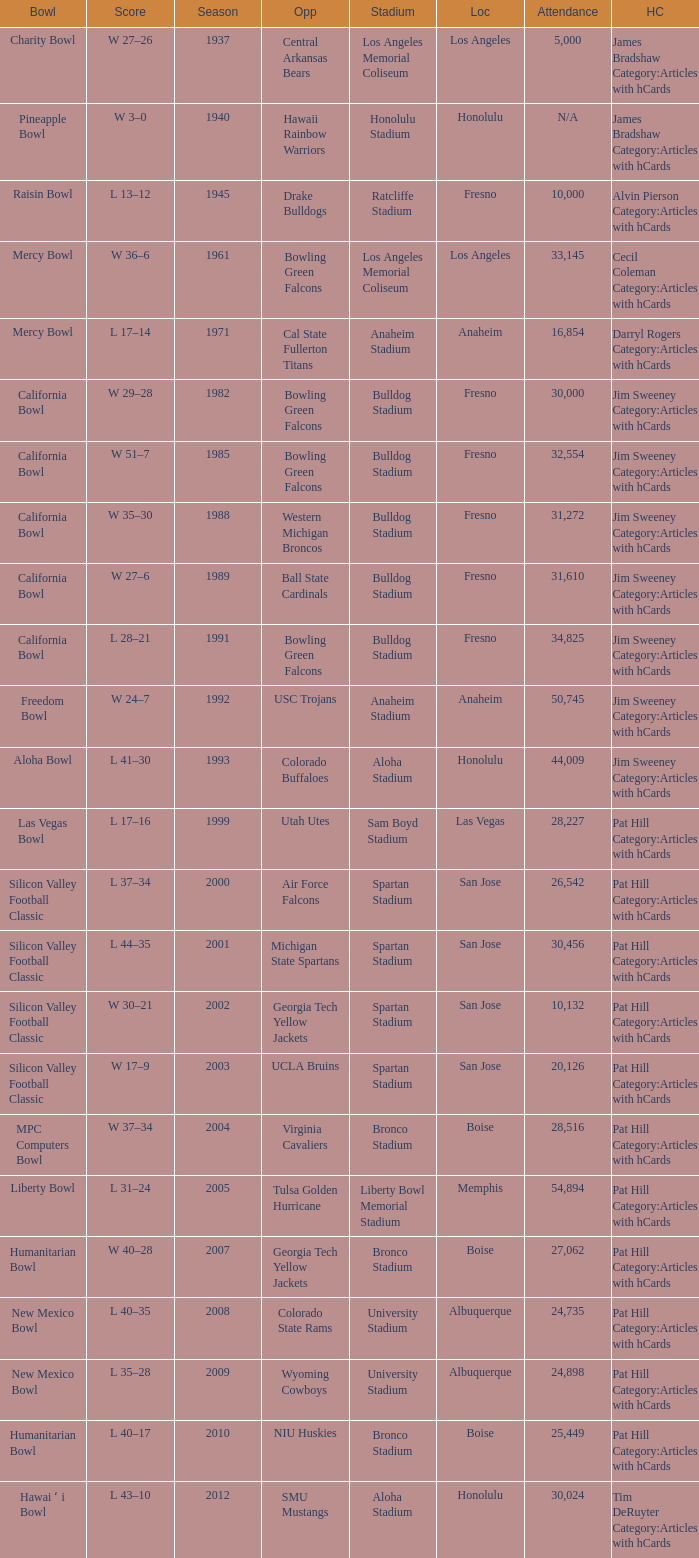Where was the California bowl played with 30,000 attending? Fresno. 